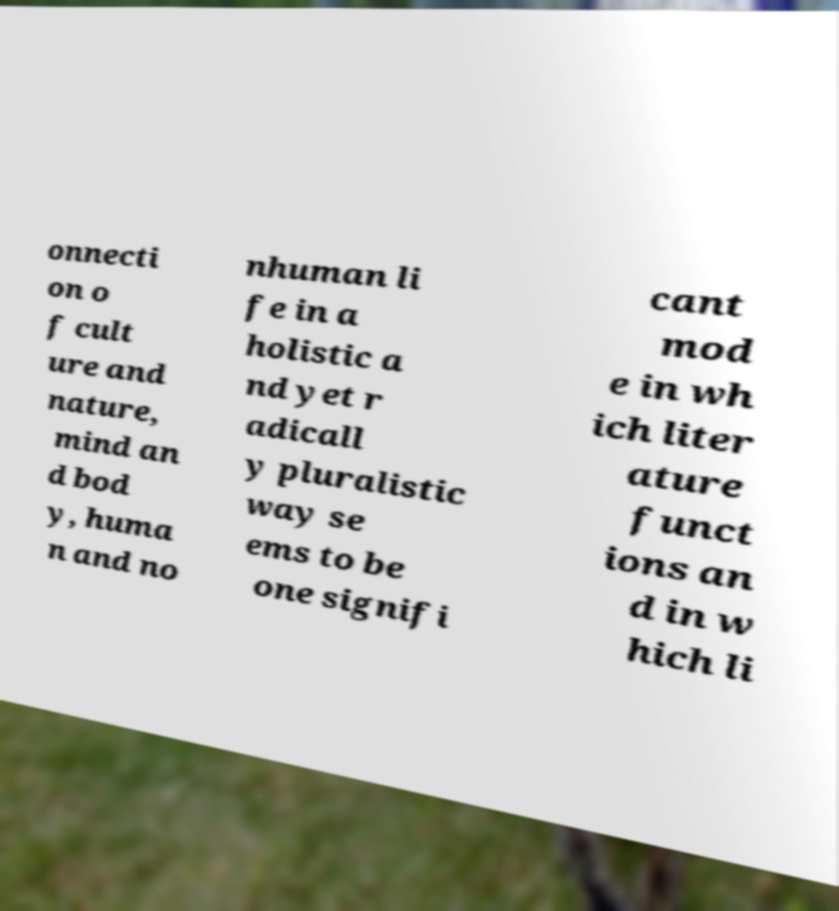Can you read and provide the text displayed in the image?This photo seems to have some interesting text. Can you extract and type it out for me? onnecti on o f cult ure and nature, mind an d bod y, huma n and no nhuman li fe in a holistic a nd yet r adicall y pluralistic way se ems to be one signifi cant mod e in wh ich liter ature funct ions an d in w hich li 